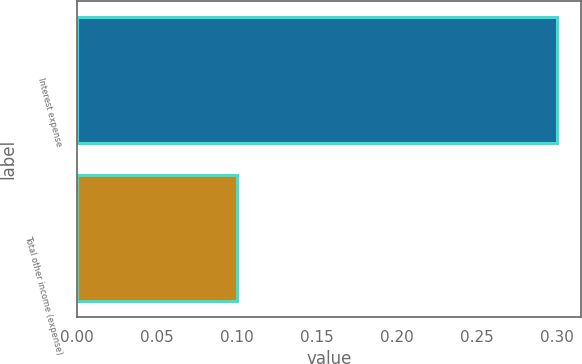Convert chart. <chart><loc_0><loc_0><loc_500><loc_500><bar_chart><fcel>Interest expense<fcel>Total other income (expense)<nl><fcel>0.3<fcel>0.1<nl></chart> 